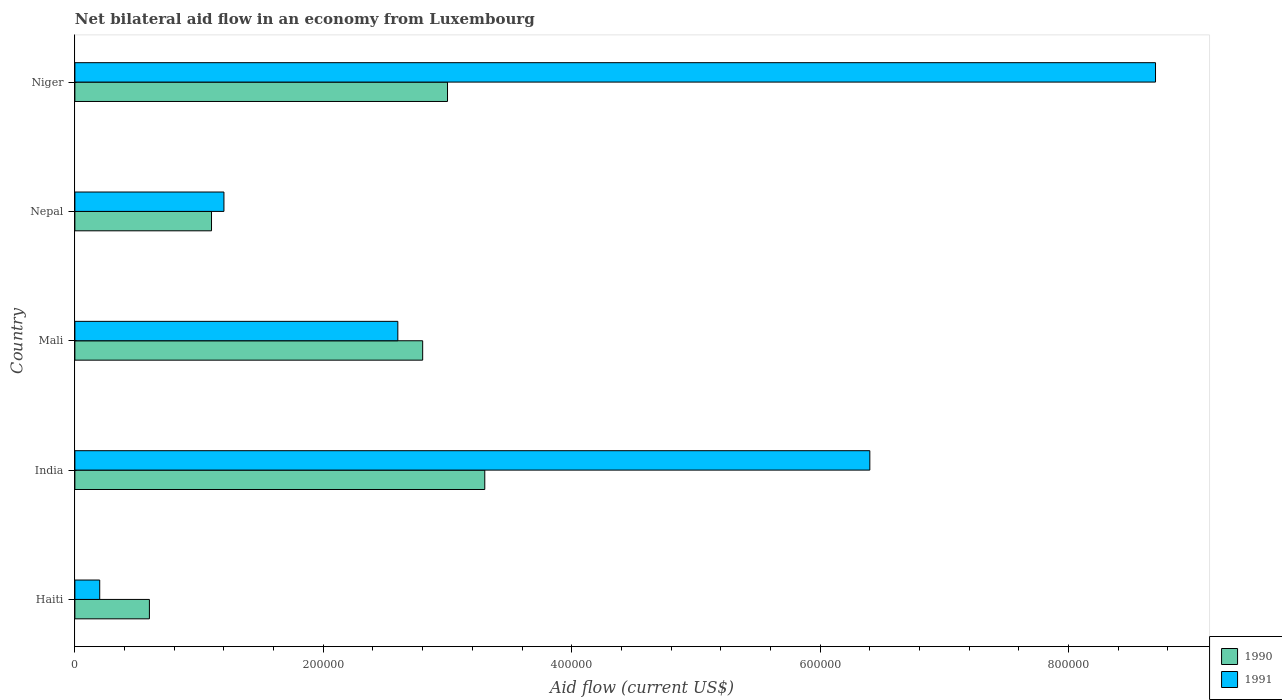How many groups of bars are there?
Your response must be concise. 5. Are the number of bars per tick equal to the number of legend labels?
Make the answer very short. Yes. Are the number of bars on each tick of the Y-axis equal?
Make the answer very short. Yes. How many bars are there on the 3rd tick from the bottom?
Provide a succinct answer. 2. What is the label of the 1st group of bars from the top?
Your response must be concise. Niger. In how many cases, is the number of bars for a given country not equal to the number of legend labels?
Your answer should be compact. 0. What is the net bilateral aid flow in 1991 in Mali?
Provide a succinct answer. 2.60e+05. In which country was the net bilateral aid flow in 1991 maximum?
Your answer should be very brief. Niger. In which country was the net bilateral aid flow in 1991 minimum?
Offer a very short reply. Haiti. What is the total net bilateral aid flow in 1990 in the graph?
Your answer should be very brief. 1.08e+06. What is the difference between the net bilateral aid flow in 1990 in Mali and that in Niger?
Give a very brief answer. -2.00e+04. What is the difference between the net bilateral aid flow in 1991 in Mali and the net bilateral aid flow in 1990 in Niger?
Your answer should be very brief. -4.00e+04. What is the average net bilateral aid flow in 1991 per country?
Offer a terse response. 3.82e+05. What is the difference between the net bilateral aid flow in 1990 and net bilateral aid flow in 1991 in Niger?
Your answer should be compact. -5.70e+05. In how many countries, is the net bilateral aid flow in 1990 greater than 400000 US$?
Provide a succinct answer. 0. What is the difference between the highest and the lowest net bilateral aid flow in 1991?
Your answer should be very brief. 8.50e+05. In how many countries, is the net bilateral aid flow in 1990 greater than the average net bilateral aid flow in 1990 taken over all countries?
Provide a succinct answer. 3. Is the sum of the net bilateral aid flow in 1990 in Haiti and Nepal greater than the maximum net bilateral aid flow in 1991 across all countries?
Keep it short and to the point. No. What does the 1st bar from the bottom in Nepal represents?
Provide a succinct answer. 1990. How many bars are there?
Ensure brevity in your answer.  10. Are all the bars in the graph horizontal?
Keep it short and to the point. Yes. Does the graph contain any zero values?
Offer a very short reply. No. Does the graph contain grids?
Provide a short and direct response. No. What is the title of the graph?
Provide a succinct answer. Net bilateral aid flow in an economy from Luxembourg. Does "1967" appear as one of the legend labels in the graph?
Your answer should be very brief. No. What is the label or title of the X-axis?
Provide a short and direct response. Aid flow (current US$). What is the label or title of the Y-axis?
Offer a very short reply. Country. What is the Aid flow (current US$) in 1991 in Haiti?
Make the answer very short. 2.00e+04. What is the Aid flow (current US$) of 1991 in India?
Make the answer very short. 6.40e+05. What is the Aid flow (current US$) in 1990 in Nepal?
Provide a short and direct response. 1.10e+05. What is the Aid flow (current US$) of 1990 in Niger?
Your response must be concise. 3.00e+05. What is the Aid flow (current US$) in 1991 in Niger?
Offer a very short reply. 8.70e+05. Across all countries, what is the maximum Aid flow (current US$) of 1990?
Ensure brevity in your answer.  3.30e+05. Across all countries, what is the maximum Aid flow (current US$) in 1991?
Provide a short and direct response. 8.70e+05. Across all countries, what is the minimum Aid flow (current US$) in 1991?
Your answer should be very brief. 2.00e+04. What is the total Aid flow (current US$) in 1990 in the graph?
Ensure brevity in your answer.  1.08e+06. What is the total Aid flow (current US$) in 1991 in the graph?
Make the answer very short. 1.91e+06. What is the difference between the Aid flow (current US$) of 1990 in Haiti and that in India?
Your answer should be very brief. -2.70e+05. What is the difference between the Aid flow (current US$) in 1991 in Haiti and that in India?
Make the answer very short. -6.20e+05. What is the difference between the Aid flow (current US$) of 1991 in Haiti and that in Nepal?
Make the answer very short. -1.00e+05. What is the difference between the Aid flow (current US$) of 1990 in Haiti and that in Niger?
Your answer should be compact. -2.40e+05. What is the difference between the Aid flow (current US$) of 1991 in Haiti and that in Niger?
Give a very brief answer. -8.50e+05. What is the difference between the Aid flow (current US$) of 1991 in India and that in Nepal?
Keep it short and to the point. 5.20e+05. What is the difference between the Aid flow (current US$) of 1990 in India and that in Niger?
Provide a short and direct response. 3.00e+04. What is the difference between the Aid flow (current US$) of 1990 in Mali and that in Niger?
Ensure brevity in your answer.  -2.00e+04. What is the difference between the Aid flow (current US$) of 1991 in Mali and that in Niger?
Offer a very short reply. -6.10e+05. What is the difference between the Aid flow (current US$) in 1990 in Nepal and that in Niger?
Give a very brief answer. -1.90e+05. What is the difference between the Aid flow (current US$) in 1991 in Nepal and that in Niger?
Make the answer very short. -7.50e+05. What is the difference between the Aid flow (current US$) of 1990 in Haiti and the Aid flow (current US$) of 1991 in India?
Your response must be concise. -5.80e+05. What is the difference between the Aid flow (current US$) in 1990 in Haiti and the Aid flow (current US$) in 1991 in Mali?
Keep it short and to the point. -2.00e+05. What is the difference between the Aid flow (current US$) in 1990 in Haiti and the Aid flow (current US$) in 1991 in Nepal?
Provide a short and direct response. -6.00e+04. What is the difference between the Aid flow (current US$) of 1990 in Haiti and the Aid flow (current US$) of 1991 in Niger?
Your response must be concise. -8.10e+05. What is the difference between the Aid flow (current US$) in 1990 in India and the Aid flow (current US$) in 1991 in Mali?
Offer a terse response. 7.00e+04. What is the difference between the Aid flow (current US$) of 1990 in India and the Aid flow (current US$) of 1991 in Niger?
Ensure brevity in your answer.  -5.40e+05. What is the difference between the Aid flow (current US$) of 1990 in Mali and the Aid flow (current US$) of 1991 in Niger?
Your response must be concise. -5.90e+05. What is the difference between the Aid flow (current US$) of 1990 in Nepal and the Aid flow (current US$) of 1991 in Niger?
Your answer should be very brief. -7.60e+05. What is the average Aid flow (current US$) of 1990 per country?
Offer a very short reply. 2.16e+05. What is the average Aid flow (current US$) in 1991 per country?
Offer a very short reply. 3.82e+05. What is the difference between the Aid flow (current US$) in 1990 and Aid flow (current US$) in 1991 in India?
Offer a terse response. -3.10e+05. What is the difference between the Aid flow (current US$) of 1990 and Aid flow (current US$) of 1991 in Niger?
Your answer should be very brief. -5.70e+05. What is the ratio of the Aid flow (current US$) of 1990 in Haiti to that in India?
Your answer should be very brief. 0.18. What is the ratio of the Aid flow (current US$) in 1991 in Haiti to that in India?
Your answer should be very brief. 0.03. What is the ratio of the Aid flow (current US$) in 1990 in Haiti to that in Mali?
Offer a terse response. 0.21. What is the ratio of the Aid flow (current US$) of 1991 in Haiti to that in Mali?
Make the answer very short. 0.08. What is the ratio of the Aid flow (current US$) of 1990 in Haiti to that in Nepal?
Keep it short and to the point. 0.55. What is the ratio of the Aid flow (current US$) of 1991 in Haiti to that in Nepal?
Your response must be concise. 0.17. What is the ratio of the Aid flow (current US$) in 1991 in Haiti to that in Niger?
Your answer should be compact. 0.02. What is the ratio of the Aid flow (current US$) of 1990 in India to that in Mali?
Provide a short and direct response. 1.18. What is the ratio of the Aid flow (current US$) in 1991 in India to that in Mali?
Keep it short and to the point. 2.46. What is the ratio of the Aid flow (current US$) in 1990 in India to that in Nepal?
Your response must be concise. 3. What is the ratio of the Aid flow (current US$) of 1991 in India to that in Nepal?
Provide a short and direct response. 5.33. What is the ratio of the Aid flow (current US$) in 1991 in India to that in Niger?
Your answer should be very brief. 0.74. What is the ratio of the Aid flow (current US$) of 1990 in Mali to that in Nepal?
Offer a terse response. 2.55. What is the ratio of the Aid flow (current US$) in 1991 in Mali to that in Nepal?
Offer a terse response. 2.17. What is the ratio of the Aid flow (current US$) of 1991 in Mali to that in Niger?
Provide a succinct answer. 0.3. What is the ratio of the Aid flow (current US$) in 1990 in Nepal to that in Niger?
Offer a very short reply. 0.37. What is the ratio of the Aid flow (current US$) of 1991 in Nepal to that in Niger?
Your response must be concise. 0.14. What is the difference between the highest and the second highest Aid flow (current US$) in 1990?
Offer a very short reply. 3.00e+04. What is the difference between the highest and the lowest Aid flow (current US$) of 1990?
Offer a terse response. 2.70e+05. What is the difference between the highest and the lowest Aid flow (current US$) in 1991?
Give a very brief answer. 8.50e+05. 